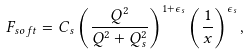<formula> <loc_0><loc_0><loc_500><loc_500>F _ { s o f t } = C _ { s } \left ( \frac { Q ^ { 2 } } { Q ^ { 2 } + Q ^ { 2 } _ { s } } \right ) ^ { 1 + \epsilon _ { s } } \left ( \frac { 1 } { x } \right ) ^ { \epsilon _ { s } } ,</formula> 